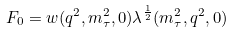Convert formula to latex. <formula><loc_0><loc_0><loc_500><loc_500>F _ { 0 } = w ( q ^ { 2 } , m _ { \tau } ^ { 2 } , 0 ) \lambda ^ { \frac { 1 } { 2 } } ( m _ { \tau } ^ { 2 } , q ^ { 2 } , 0 )</formula> 